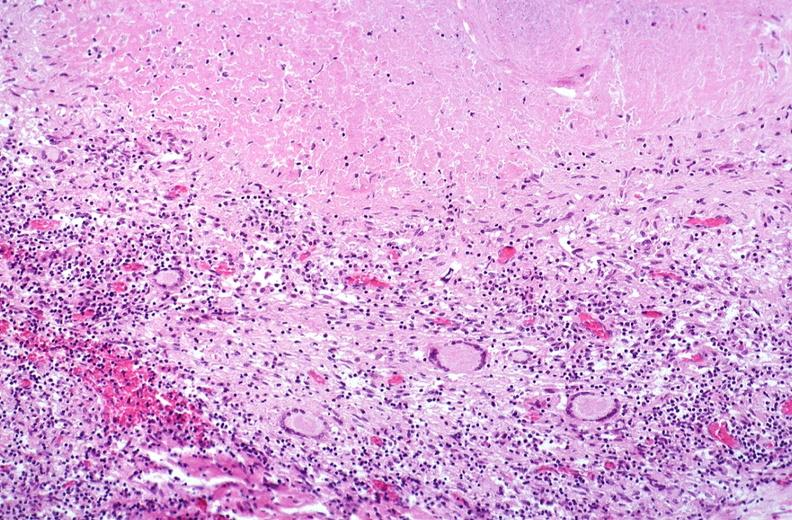does quite good liver show lung, mycobacterium tuberculosis, granulomas and giant cells?
Answer the question using a single word or phrase. No 